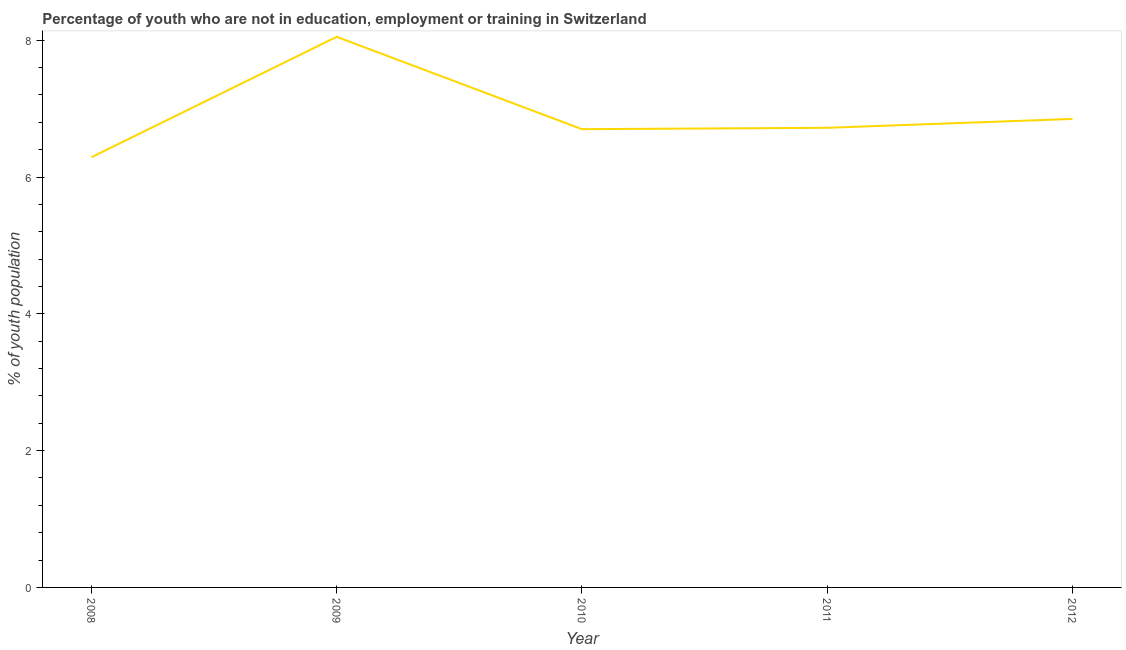What is the unemployed youth population in 2008?
Provide a short and direct response. 6.29. Across all years, what is the maximum unemployed youth population?
Your answer should be compact. 8.05. Across all years, what is the minimum unemployed youth population?
Keep it short and to the point. 6.29. What is the sum of the unemployed youth population?
Provide a succinct answer. 34.61. What is the difference between the unemployed youth population in 2009 and 2010?
Offer a terse response. 1.35. What is the average unemployed youth population per year?
Give a very brief answer. 6.92. What is the median unemployed youth population?
Offer a terse response. 6.72. What is the ratio of the unemployed youth population in 2010 to that in 2012?
Your response must be concise. 0.98. What is the difference between the highest and the second highest unemployed youth population?
Offer a very short reply. 1.2. What is the difference between the highest and the lowest unemployed youth population?
Ensure brevity in your answer.  1.76. In how many years, is the unemployed youth population greater than the average unemployed youth population taken over all years?
Keep it short and to the point. 1. Does the unemployed youth population monotonically increase over the years?
Provide a short and direct response. No. What is the difference between two consecutive major ticks on the Y-axis?
Ensure brevity in your answer.  2. Does the graph contain any zero values?
Offer a terse response. No. What is the title of the graph?
Make the answer very short. Percentage of youth who are not in education, employment or training in Switzerland. What is the label or title of the X-axis?
Keep it short and to the point. Year. What is the label or title of the Y-axis?
Offer a very short reply. % of youth population. What is the % of youth population of 2008?
Offer a terse response. 6.29. What is the % of youth population in 2009?
Give a very brief answer. 8.05. What is the % of youth population in 2010?
Offer a very short reply. 6.7. What is the % of youth population in 2011?
Keep it short and to the point. 6.72. What is the % of youth population in 2012?
Your response must be concise. 6.85. What is the difference between the % of youth population in 2008 and 2009?
Your answer should be very brief. -1.76. What is the difference between the % of youth population in 2008 and 2010?
Provide a succinct answer. -0.41. What is the difference between the % of youth population in 2008 and 2011?
Make the answer very short. -0.43. What is the difference between the % of youth population in 2008 and 2012?
Provide a short and direct response. -0.56. What is the difference between the % of youth population in 2009 and 2010?
Your answer should be very brief. 1.35. What is the difference between the % of youth population in 2009 and 2011?
Keep it short and to the point. 1.33. What is the difference between the % of youth population in 2009 and 2012?
Your response must be concise. 1.2. What is the difference between the % of youth population in 2010 and 2011?
Your response must be concise. -0.02. What is the difference between the % of youth population in 2010 and 2012?
Your answer should be very brief. -0.15. What is the difference between the % of youth population in 2011 and 2012?
Give a very brief answer. -0.13. What is the ratio of the % of youth population in 2008 to that in 2009?
Your answer should be very brief. 0.78. What is the ratio of the % of youth population in 2008 to that in 2010?
Offer a terse response. 0.94. What is the ratio of the % of youth population in 2008 to that in 2011?
Ensure brevity in your answer.  0.94. What is the ratio of the % of youth population in 2008 to that in 2012?
Offer a terse response. 0.92. What is the ratio of the % of youth population in 2009 to that in 2010?
Offer a very short reply. 1.2. What is the ratio of the % of youth population in 2009 to that in 2011?
Provide a succinct answer. 1.2. What is the ratio of the % of youth population in 2009 to that in 2012?
Provide a short and direct response. 1.18. What is the ratio of the % of youth population in 2010 to that in 2011?
Your answer should be compact. 1. 